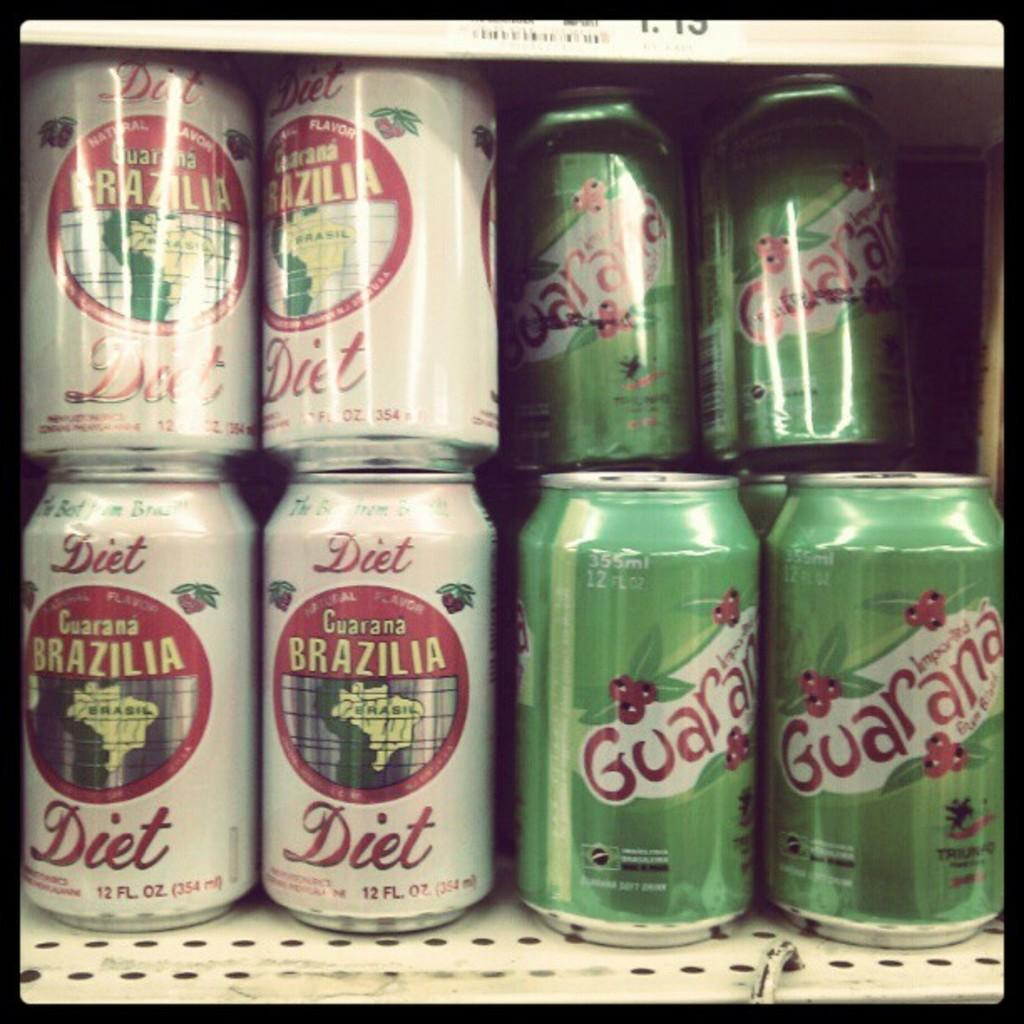Provide a one-sentence caption for the provided image. Brazilia Guarana is sold in both Diet and regular flavors. 